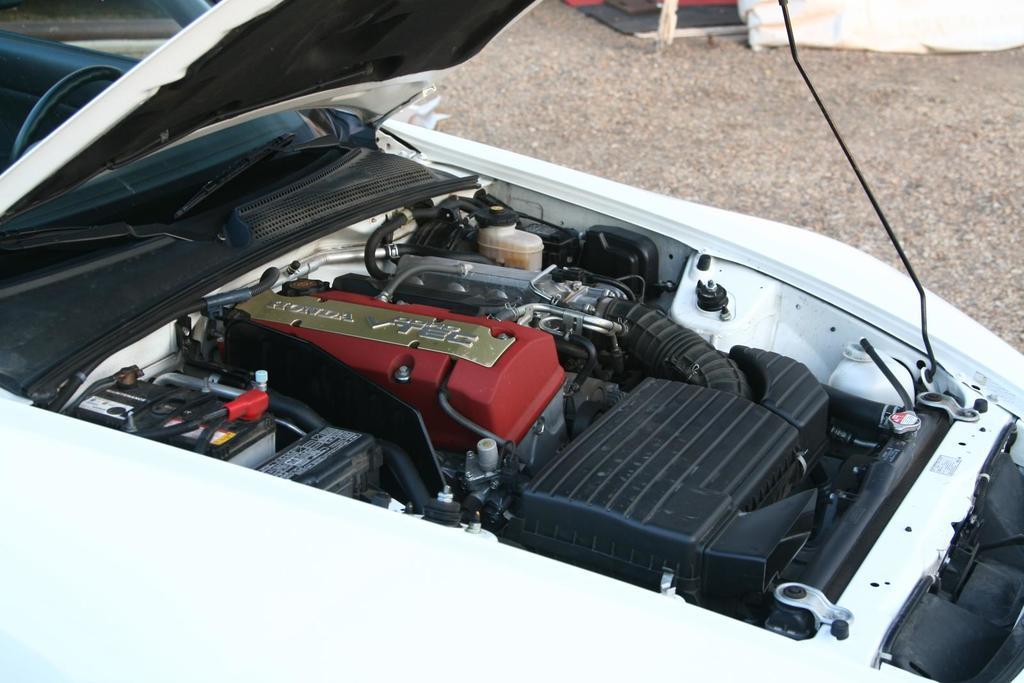How would you summarize this image in a sentence or two? In this image in the foreground there is one vehicle and engine is visible, in the background there is walkway and some objects. 